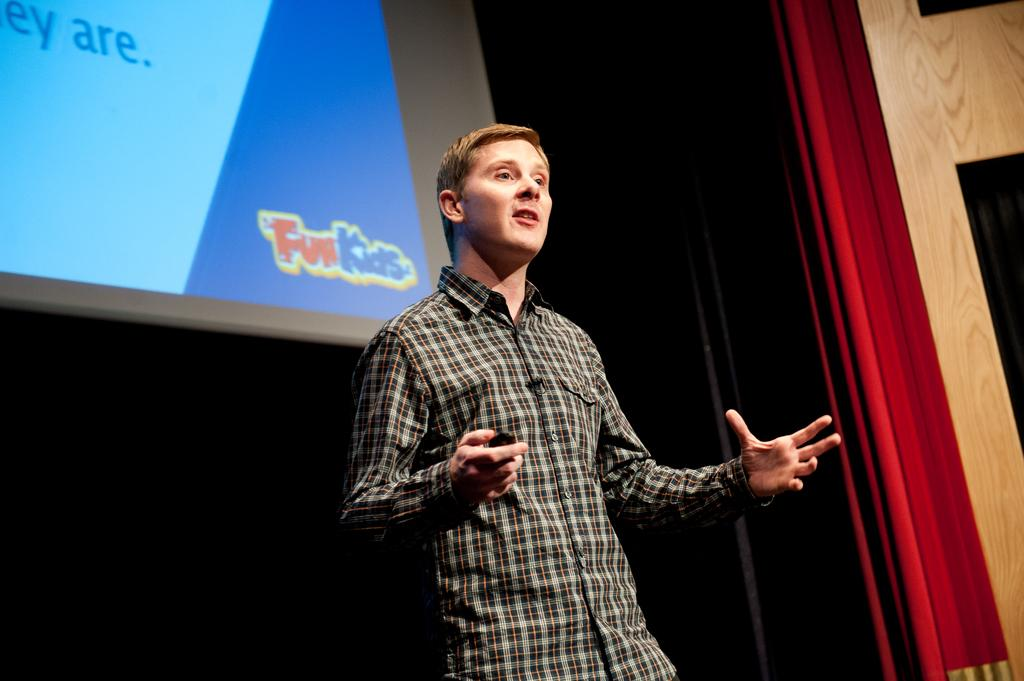Who is present in the image? There is a man in the image. What is the man wearing? The man is wearing a checked shirt. What is the man doing in the image? The man is talking and holding something. What can be seen in the background of the image? There is a screen in the background of the image. What type of window treatment is present in the image? There are curtains in the image. What type of government is being discussed in the image? There is no indication in the image that the man is discussing any type of government. What tool is the man using to fix the competition in the image? There is no competition or tool present in the image. 